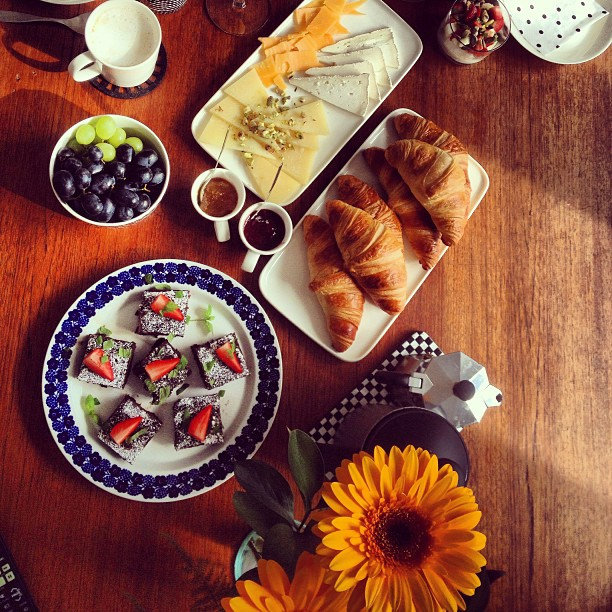<image>How good would this food taste? It's ambiguous to determine how good this food would taste without tasting it. How good would this food taste? I am not sure how good this food would taste. It can be very good, good or delicious. 